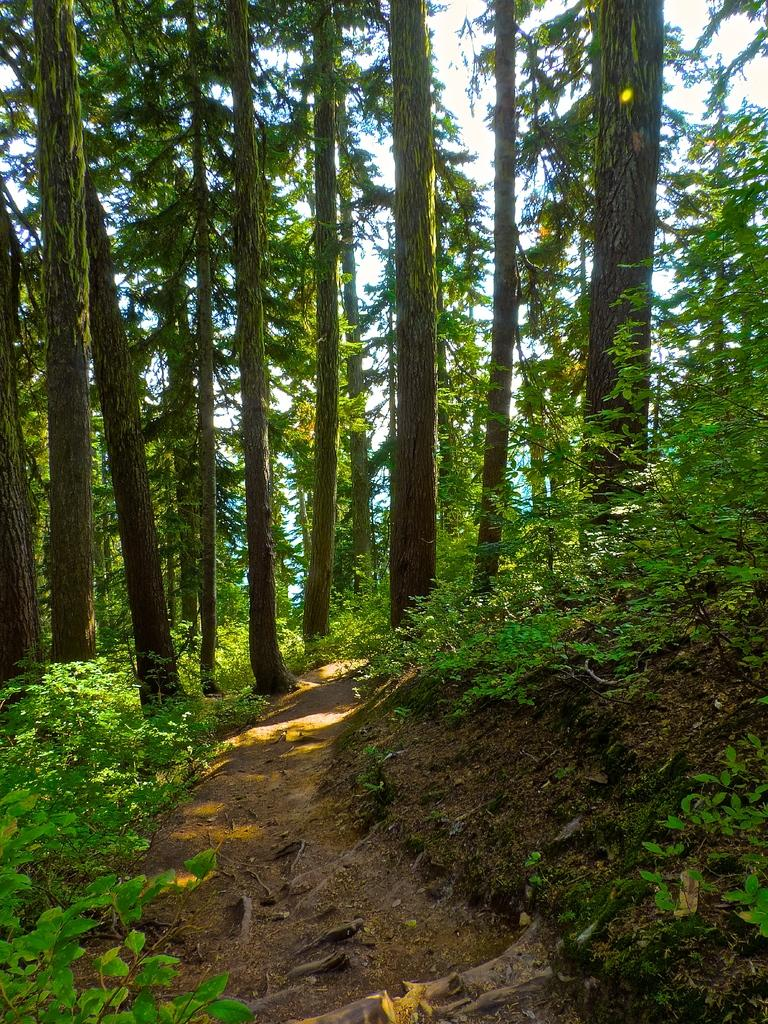What type of vegetation is present on the ground in the image? There are plants on the ground in the image. What can be seen in the background of the image? There are trees and the sky visible in the background of the image. Where is the snail located on the shelf in the image? There is no shelf or snail present in the image. 